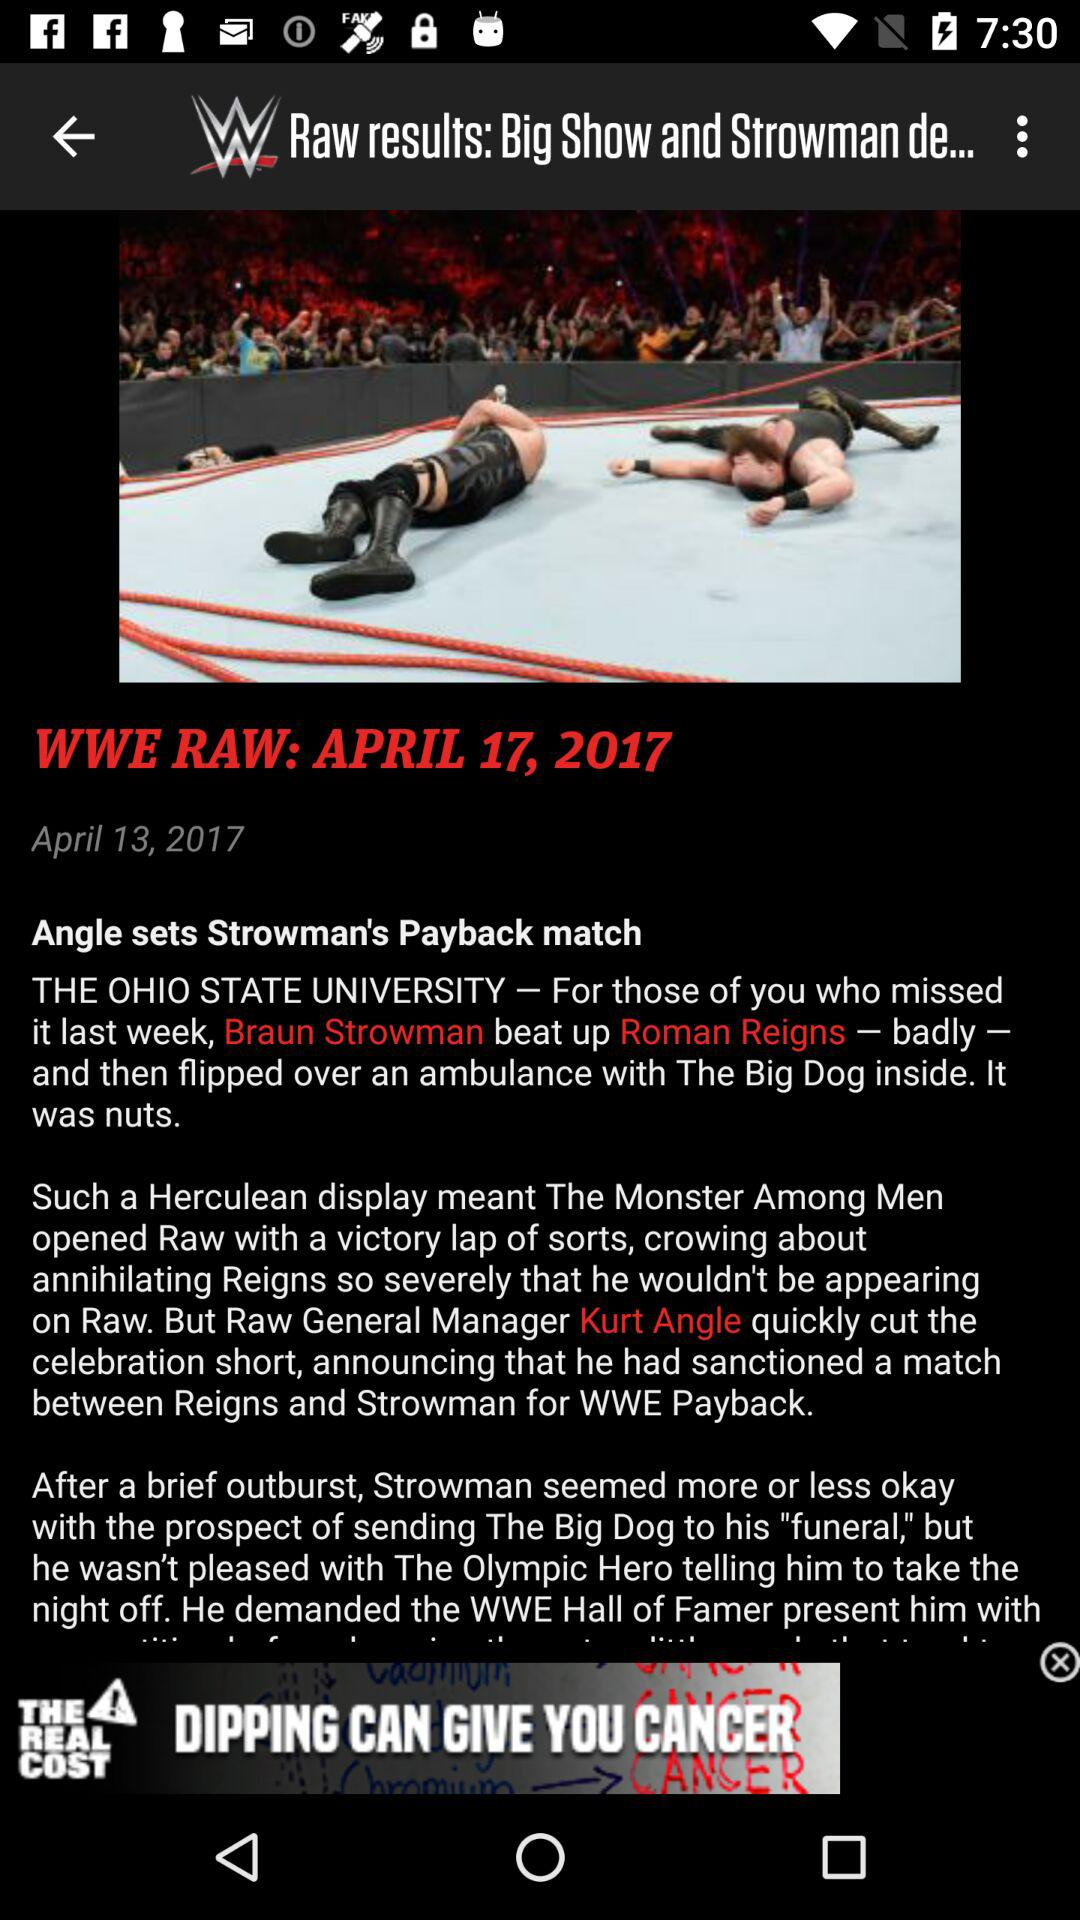What day of the week was the article posted?
When the provided information is insufficient, respond with <no answer>. <no answer> 